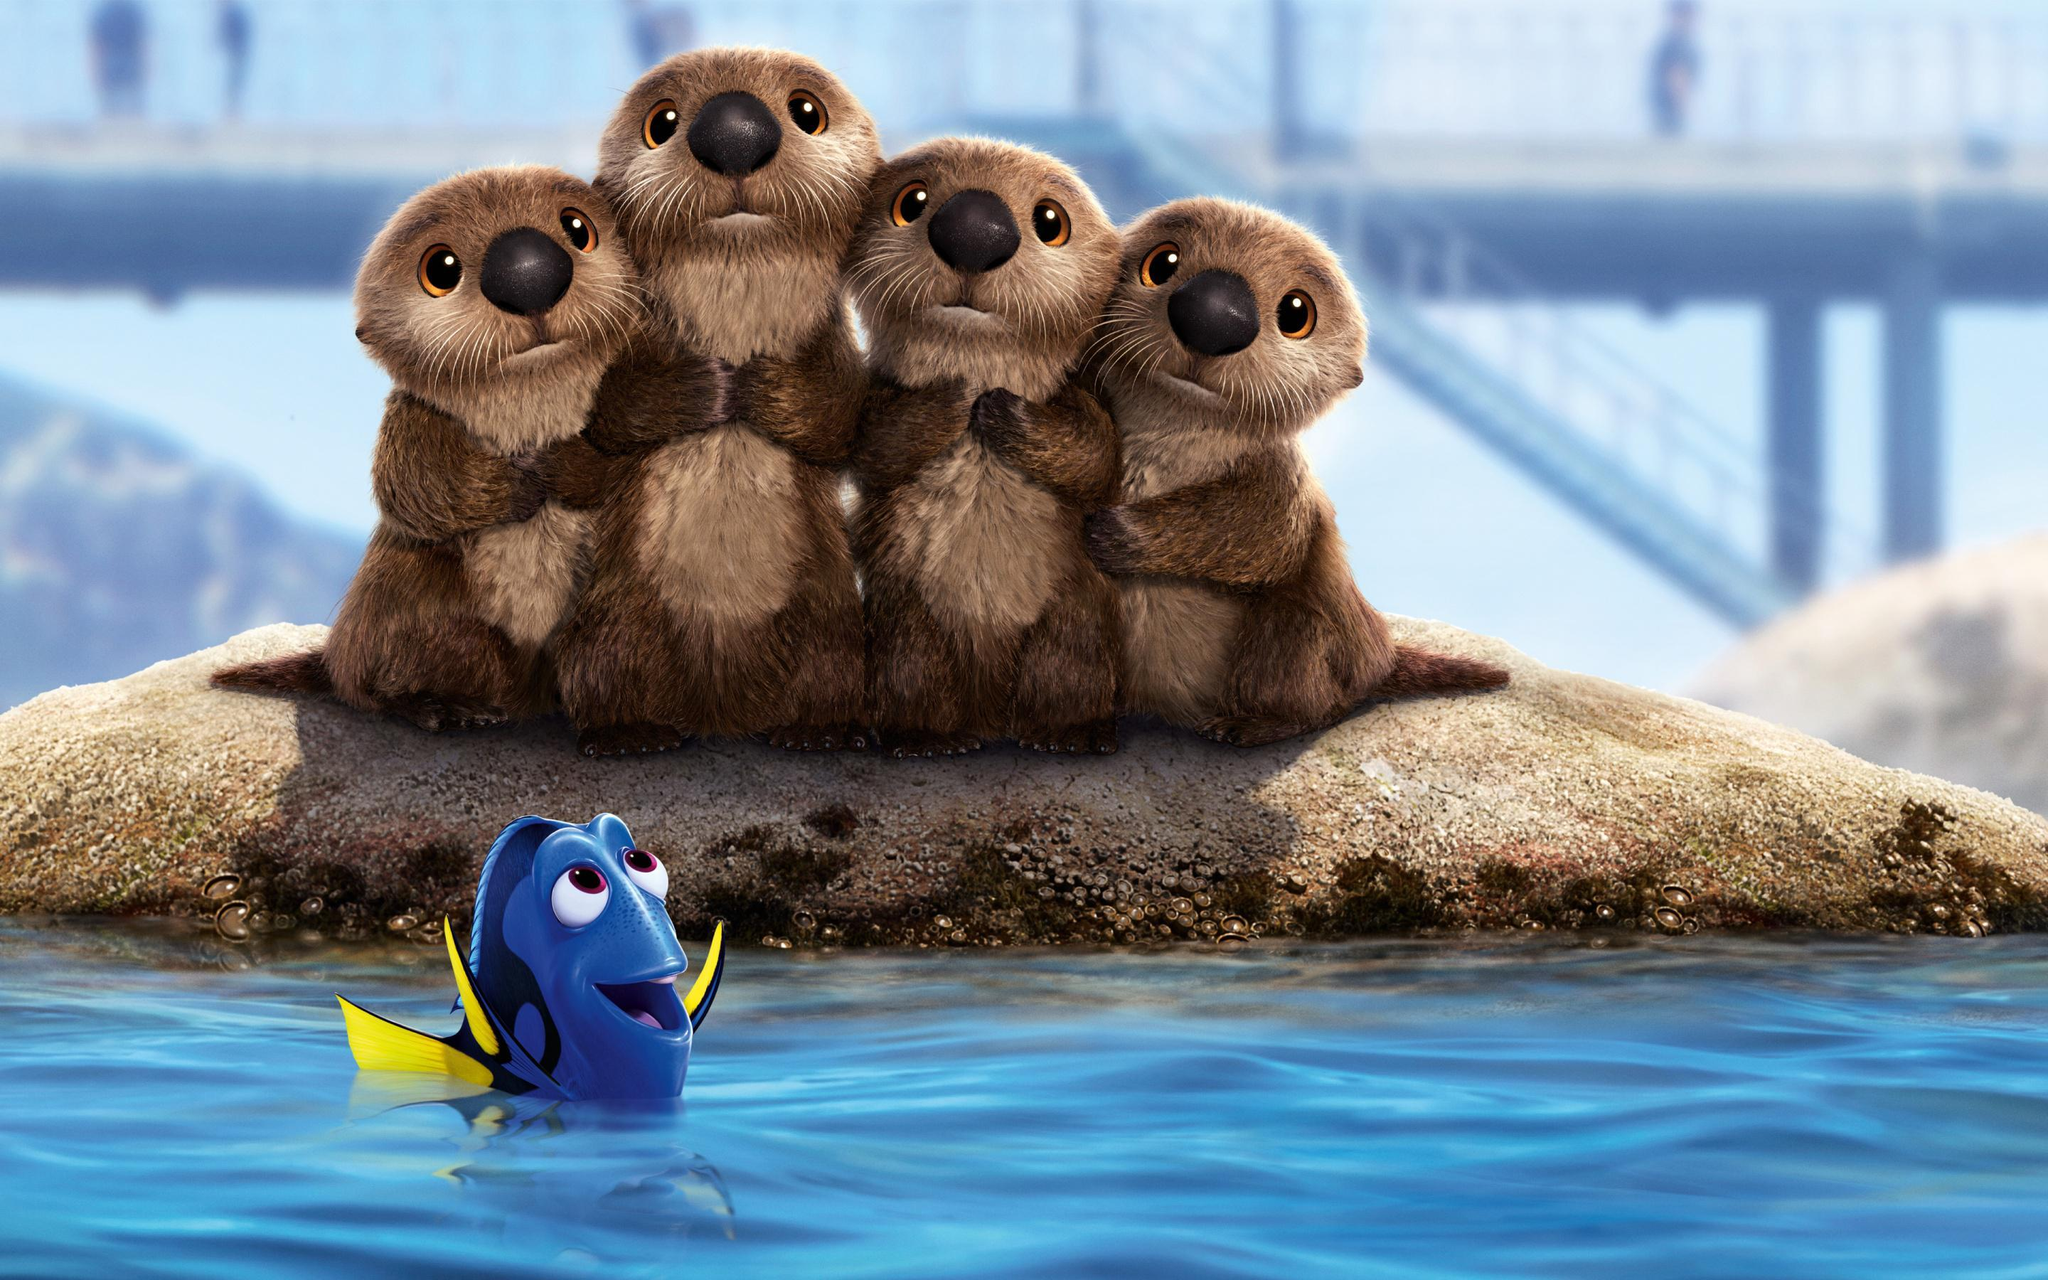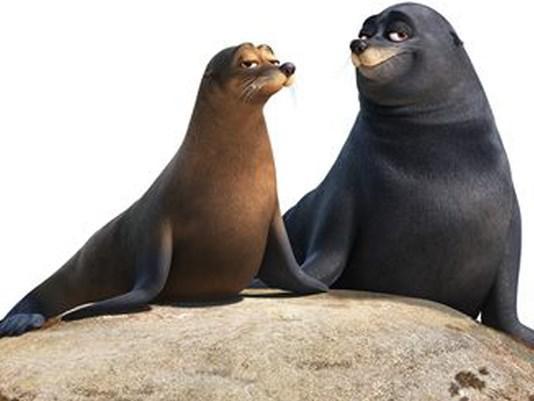The first image is the image on the left, the second image is the image on the right. Given the left and right images, does the statement "In one image, two seals are alone together on a small mound surrounded by water, and in the other image, a third seal has joined them on the mound." hold true? Answer yes or no. No. The first image is the image on the left, the second image is the image on the right. For the images shown, is this caption "One image shoes three seals interacting with a small green bucket, and the other image shows two seals on a rock, one black and one brown." true? Answer yes or no. No. 